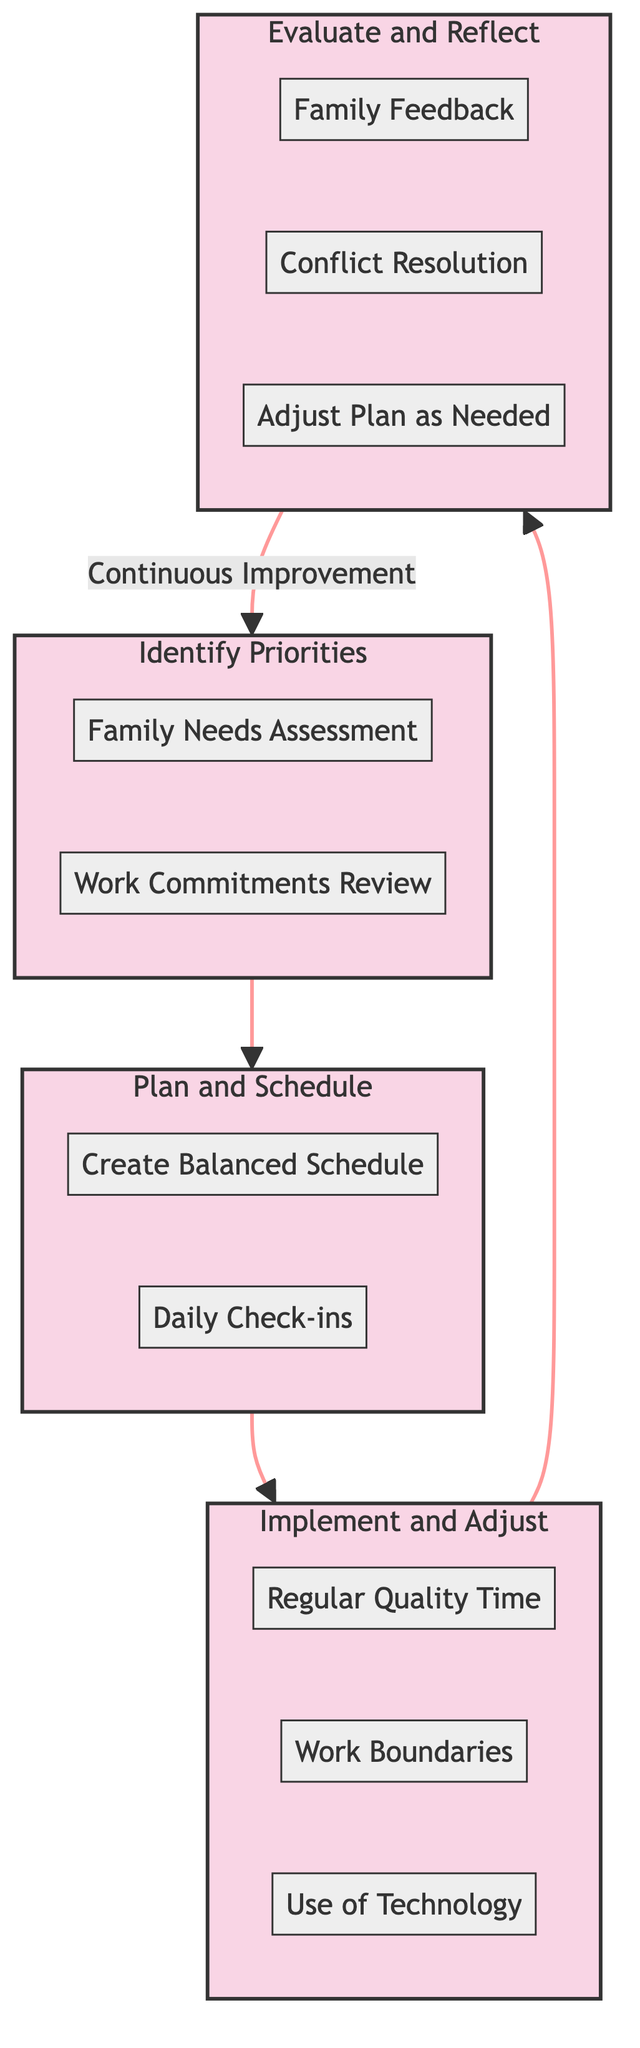What are the stages in the diagram? The diagram consists of four stages: Identify Priorities, Plan and Schedule, Implement and Adjust, and Evaluate and Reflect. Each stage has a specific focus to help balance work and family time.
Answer: Identify Priorities, Plan and Schedule, Implement and Adjust, Evaluate and Reflect How many steps are there in the Implement stage? In the Implement stage, there are three steps: Regular Quality Time, Work Boundaries, and Use of Technology. This indicates the various measures to implement the plan effectively.
Answer: Three What step comes after Work Boundaries? After Work Boundaries, the next step in the Implement stage is the Use of Technology. This shows the sequential task management within the stages of balancing work and family.
Answer: Use of Technology Which step is part of the Evaluate and Reflect stage? The Evaluate and Reflect stage includes Family Feedback, Conflict Resolution, and Adjust Plan as Needed. All these steps are aimed at assessing and refining the integration of work and family commitments.
Answer: Family Feedback Which stage includes Daily Check-ins? Daily Check-ins is a step in the Plan and Schedule stage. This shows that scheduling involves regular communication to keep the plans flexible and adaptive.
Answer: Plan and Schedule What is the main goal of the Identify Priorities stage? The Identify Priorities stage aims to assess both Family Needs and Work Commitments to find the balance between work and family life. It involves understanding the requirements from both sides.
Answer: Family Needs Assessment and Work Commitments Review How does the diagram suggest addressing conflicts? The diagram suggests addressing conflicts through the Conflict Resolution step in the Evaluate and Reflect stage. This indicates a focus on resolving issues that emerge between work and family commitments.
Answer: Conflict Resolution What is the primary action in Regular Quality Time? The primary action in Regular Quality Time is to designate and protect time each day or week specifically for family activities. This step emphasizes the importance of dedicated family interaction.
Answer: Designate and protect time for family activities 